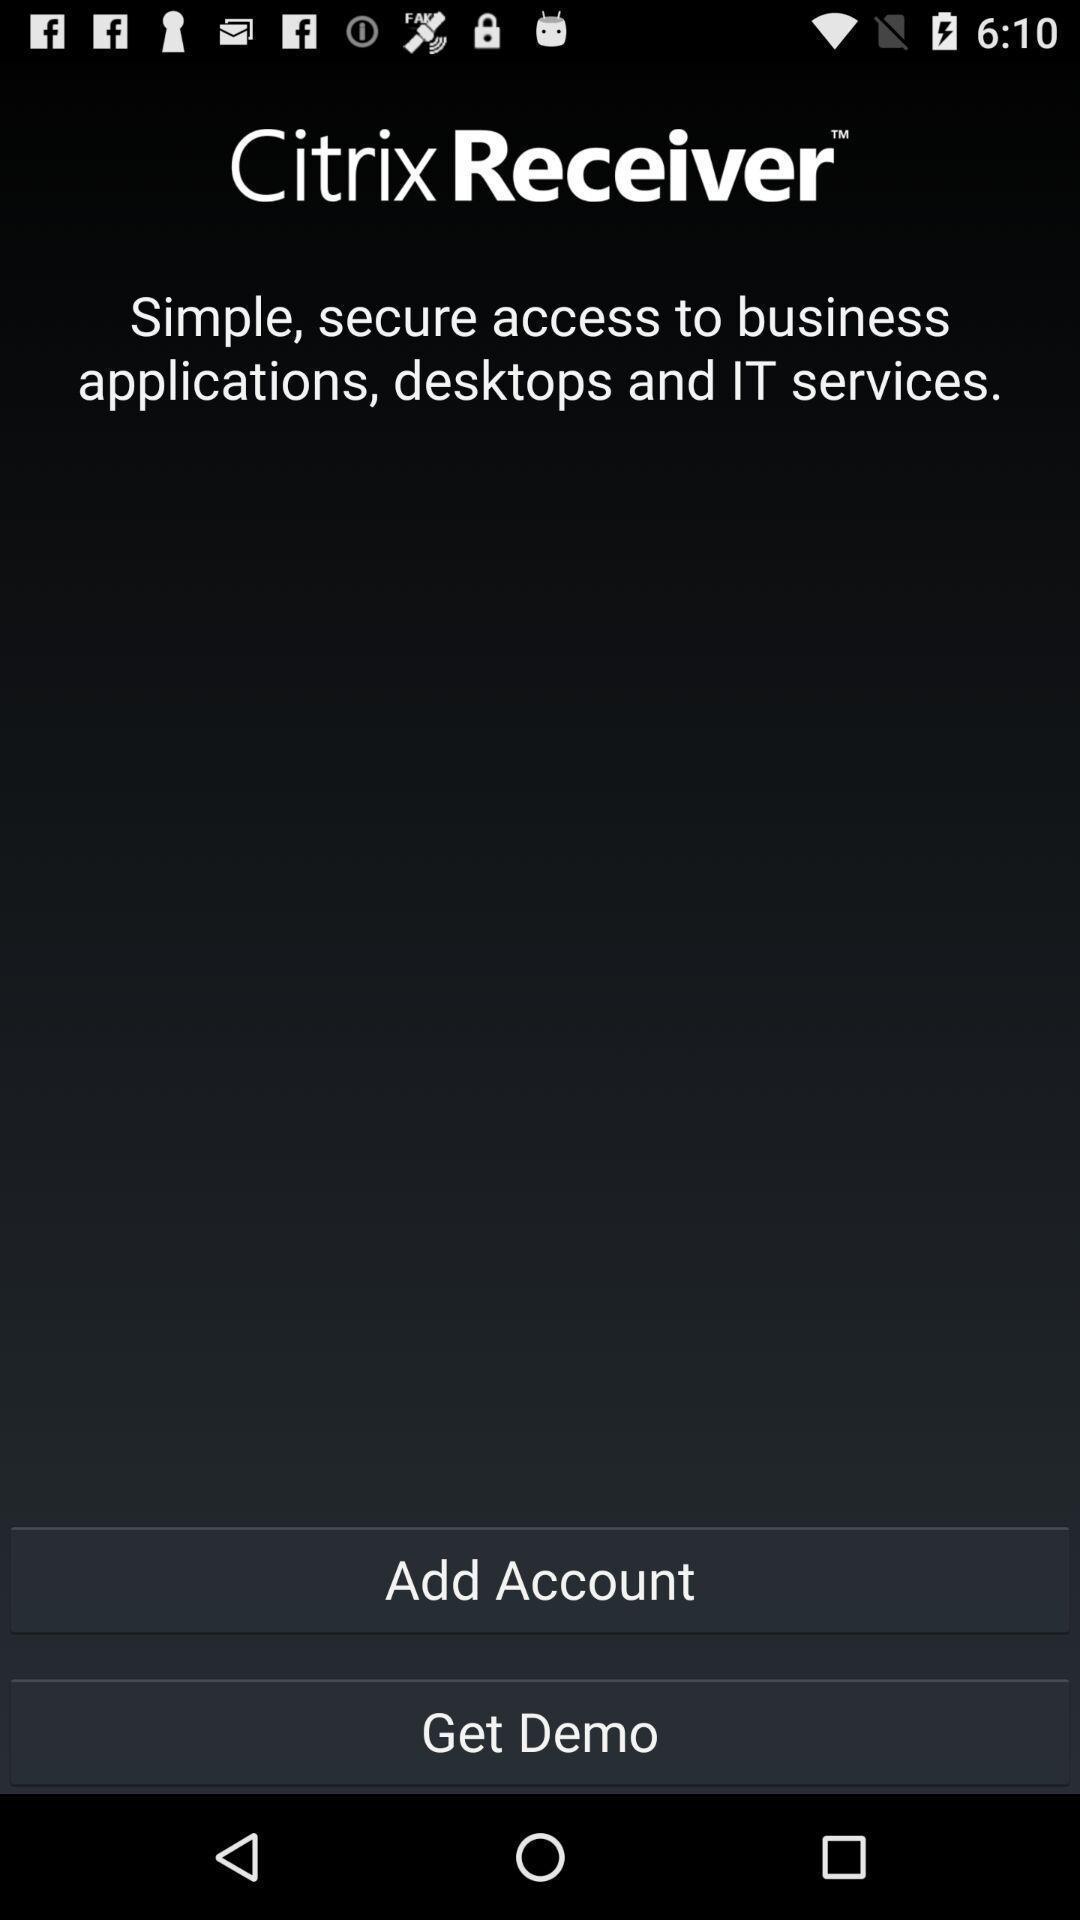What is the overall content of this screenshot? Window displaying an workspace app. 